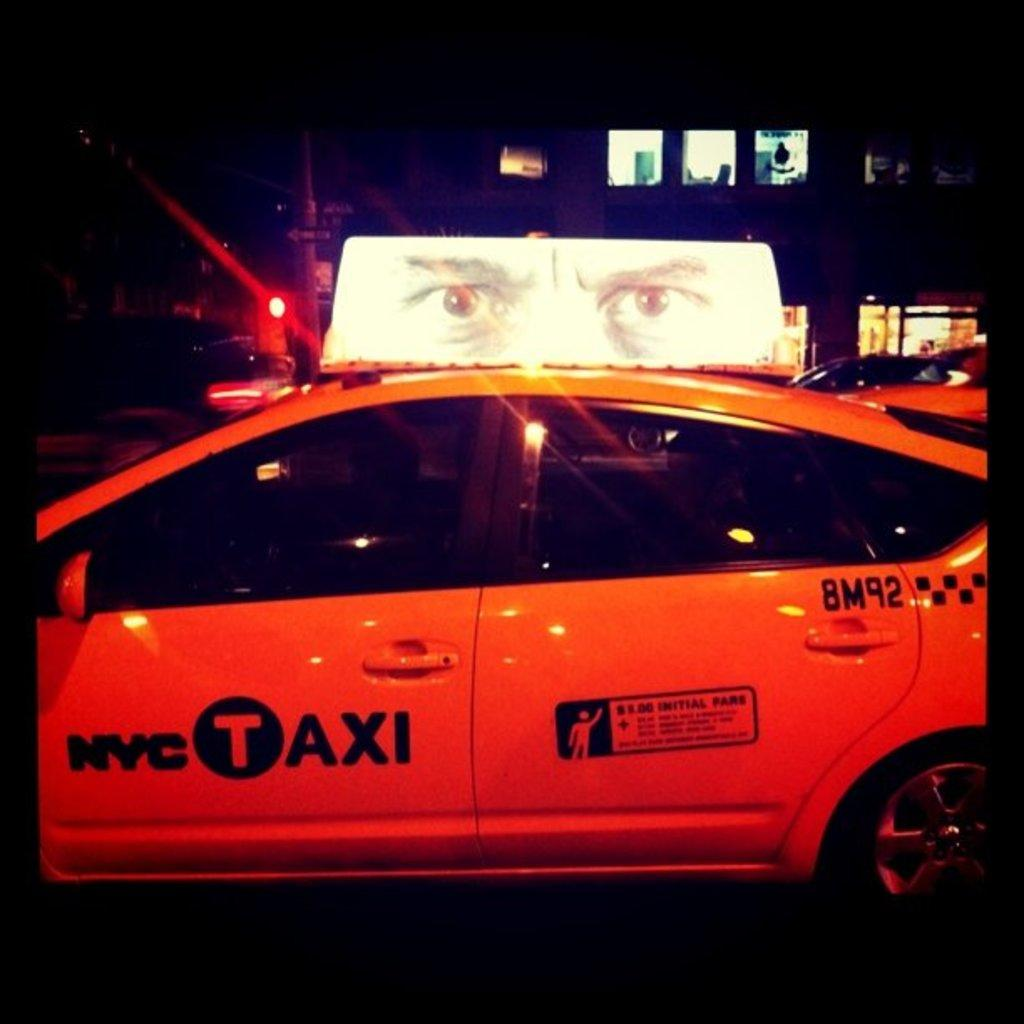<image>
Create a compact narrative representing the image presented. A yellow NYC taxi is shown on a street. 